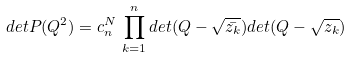<formula> <loc_0><loc_0><loc_500><loc_500>d e t P ( Q ^ { 2 } ) = c _ { n } ^ { N } \, \prod _ { k = 1 } ^ { n } d e t ( Q - \sqrt { \bar { z _ { k } } } ) d e t ( Q - \sqrt { z _ { k } } )</formula> 